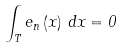Convert formula to latex. <formula><loc_0><loc_0><loc_500><loc_500>\int _ { T } e _ { n } \left ( x \right ) \, d x = 0</formula> 